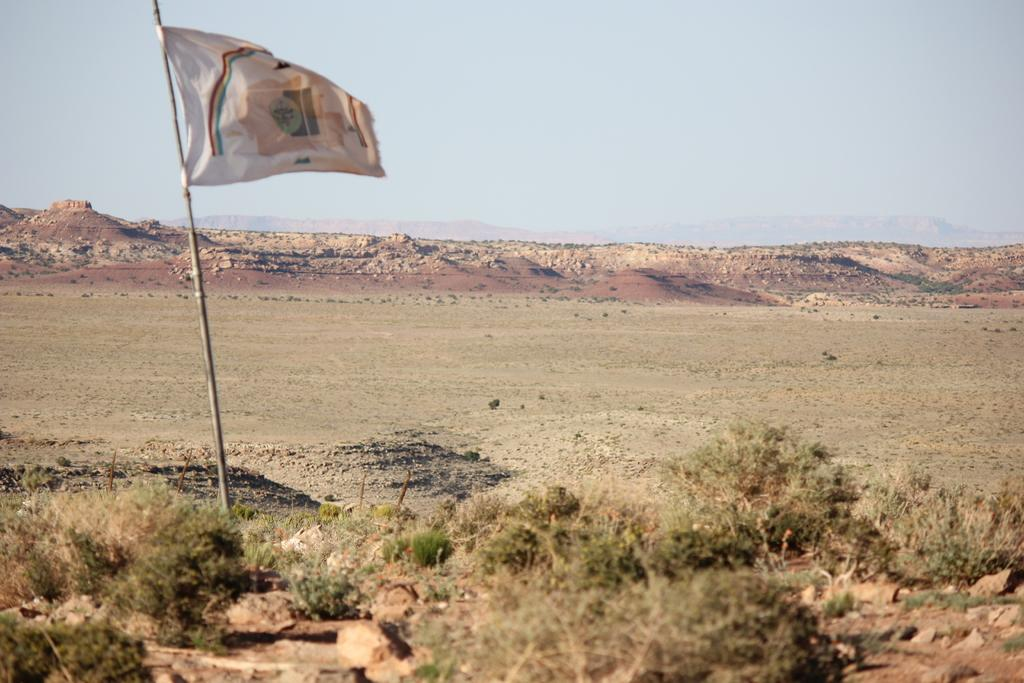What is the main object in the image? There is a flag in the image. What can be seen in the distance in the image? There are hills in the background of the image. What type of vegetation is present on the ground in the image? There are plants on the ground in the image. What is visible at the top of the image? The sky is visible at the top of the image. What type of quilt is being used to hold the flag in the image? There is no quilt present in the image, and the flag is not being held by any such object. 